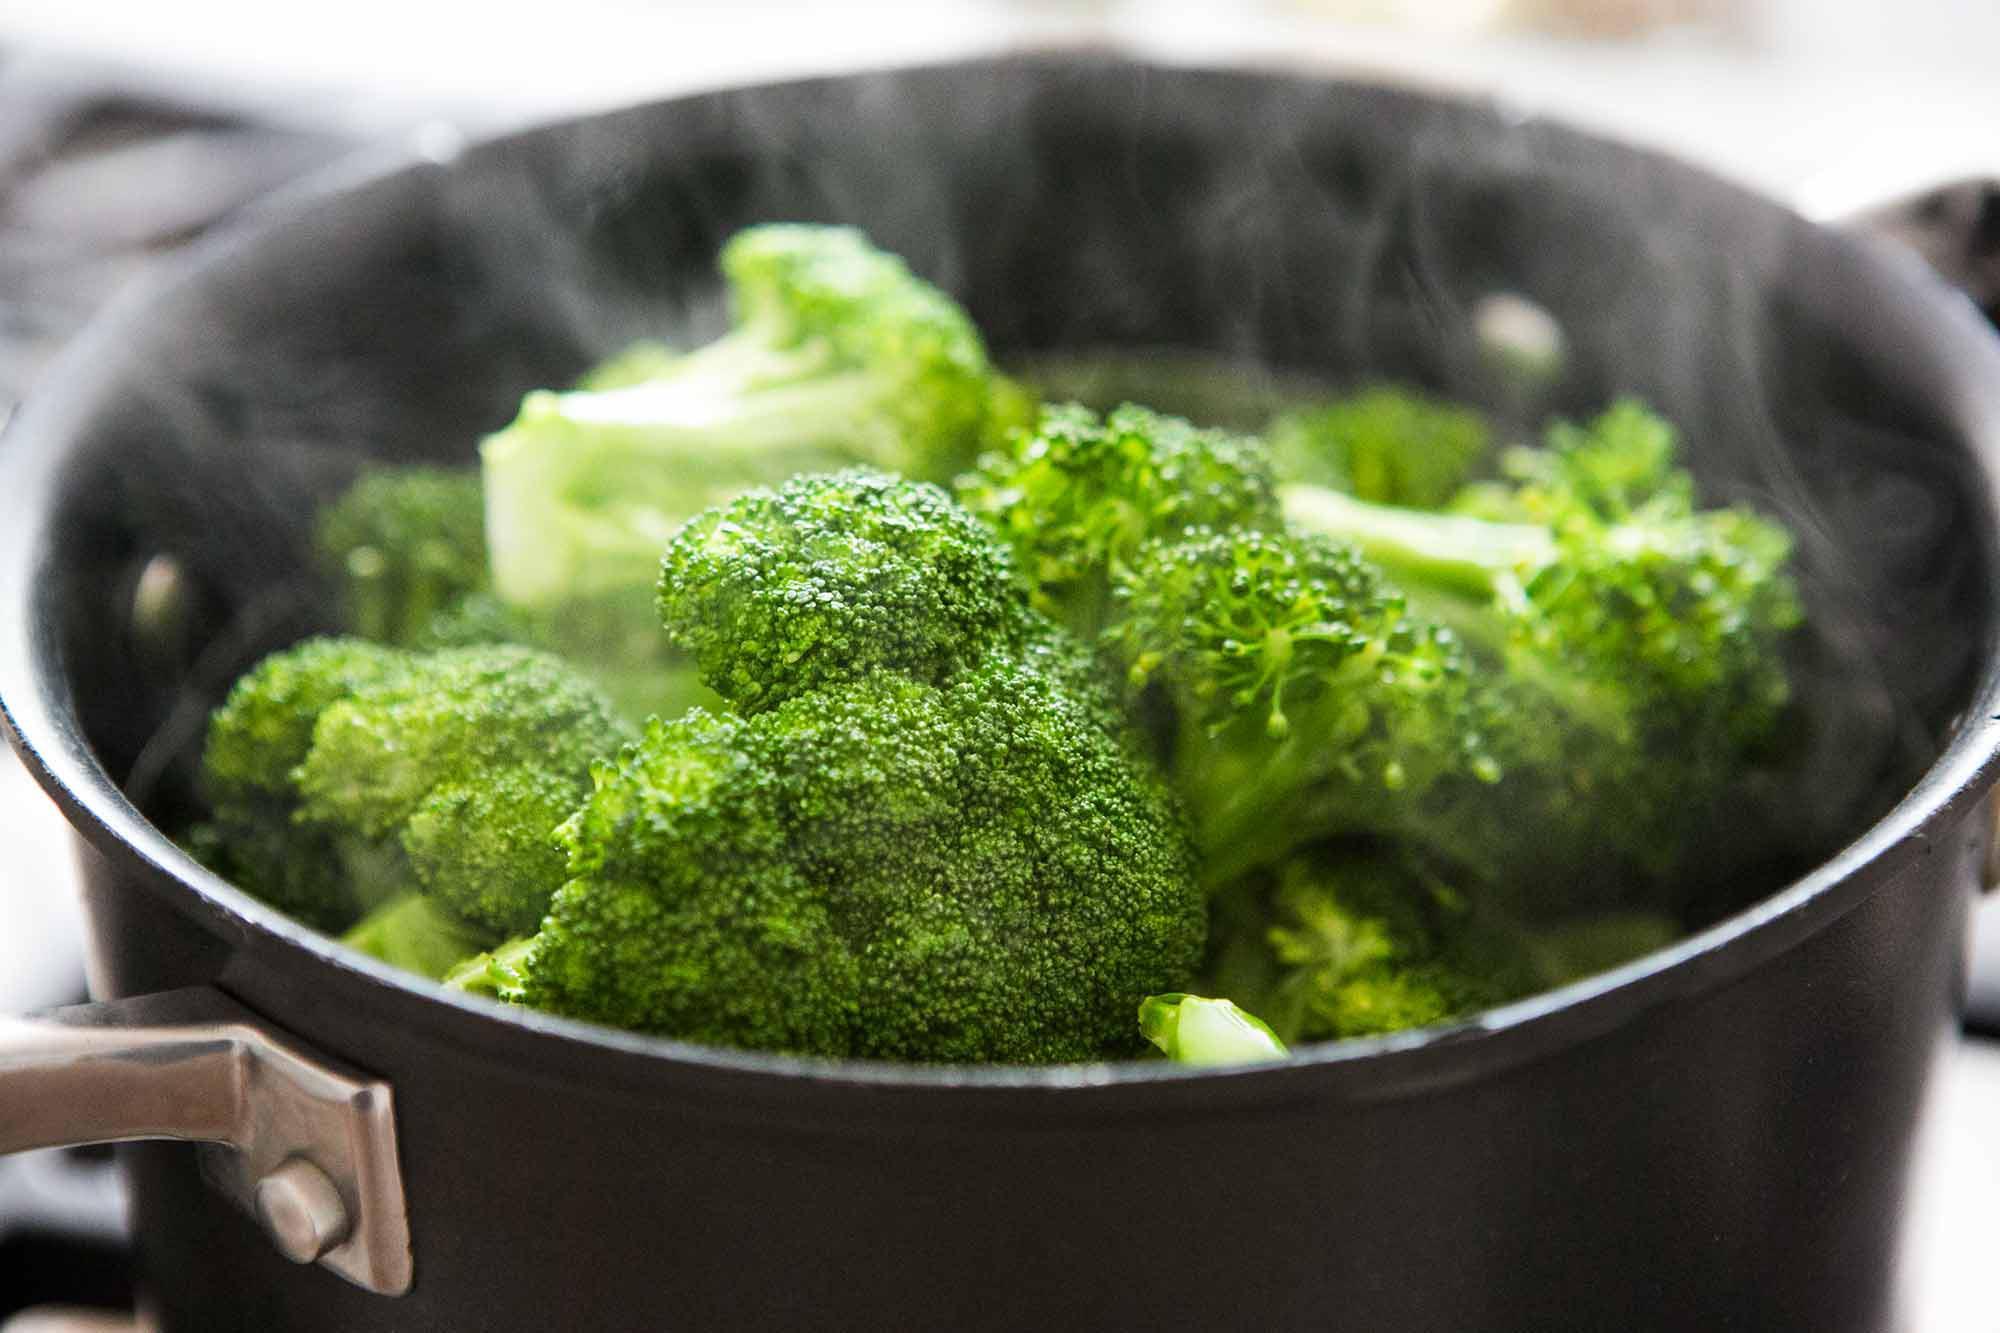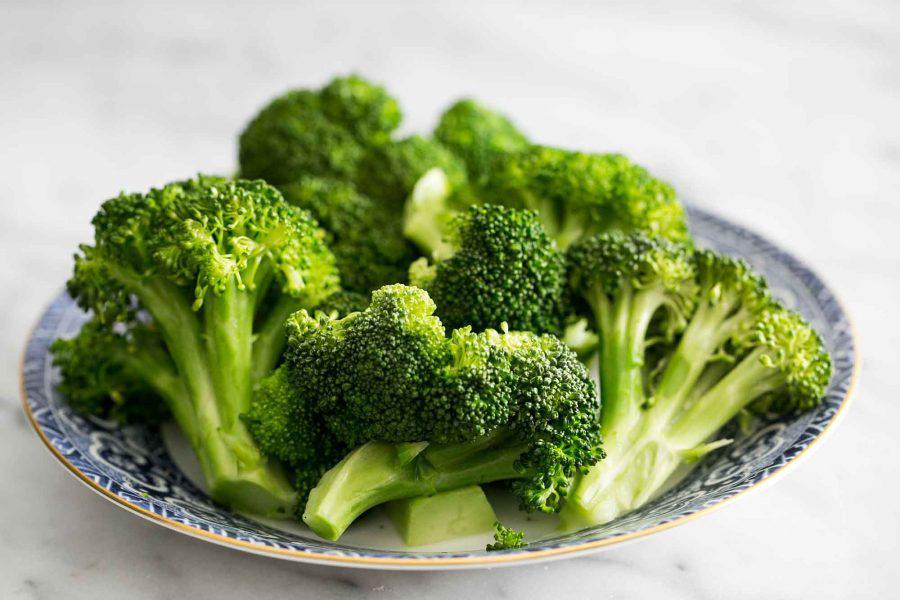The first image is the image on the left, the second image is the image on the right. For the images displayed, is the sentence "The left and right image contains a total two white plates with broccoli." factually correct? Answer yes or no. No. The first image is the image on the left, the second image is the image on the right. Assess this claim about the two images: "Each image shows broccoli florets in a white container, and one image shows broccoli florets in an oblong-shaped bowl.". Correct or not? Answer yes or no. No. 